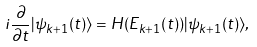Convert formula to latex. <formula><loc_0><loc_0><loc_500><loc_500>i \frac { \partial } { \partial t } | \psi _ { k + 1 } ( t ) \rangle = H ( E _ { k + 1 } ( t ) ) | \psi _ { k + 1 } ( t ) \rangle ,</formula> 